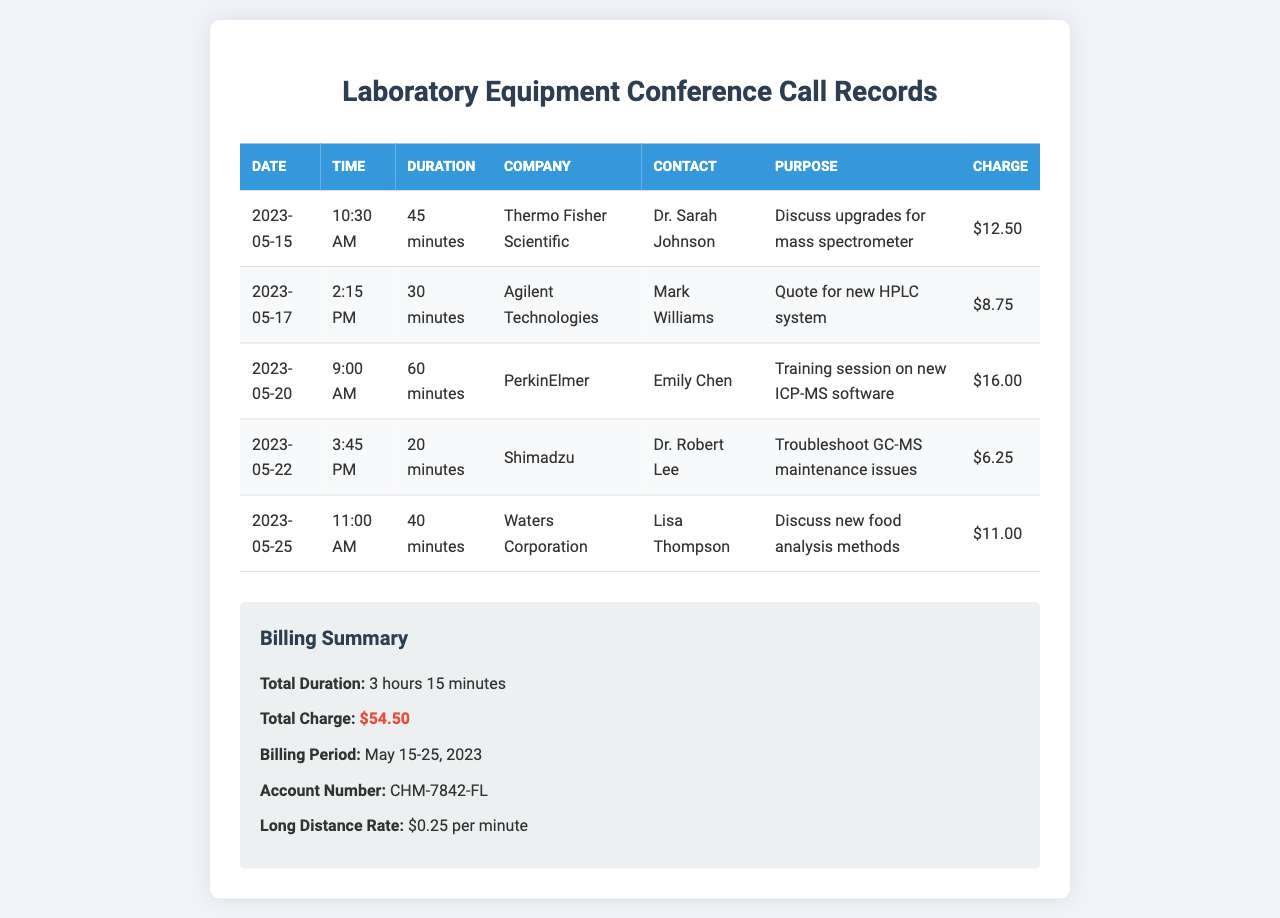What is the total charge? The total charge is the sum of all long-distance charges listed in the document.
Answer: $54.50 How many minutes was the longest call? The longest call duration listed in the document is 60 minutes.
Answer: 60 minutes Who was the contact person for Waters Corporation? The contact person for Waters Corporation mentioned in the document is Lisa Thompson.
Answer: Lisa Thompson On what date was the call with Thermo Fisher Scientific made? The call with Thermo Fisher Scientific took place on May 15, 2023.
Answer: May 15, 2023 What was the purpose of the call with Agilent Technologies? The purpose of the call with Agilent Technologies was to obtain a quote for a new HPLC system.
Answer: Quote for new HPLC system What is the total duration of all calls listed in the document? The total duration is the sum of all individual call durations, which amounts to 3 hours 15 minutes.
Answer: 3 hours 15 minutes Which company had the shortest call duration? The company with the shortest call duration listed in the document is Shimadzu, with a call duration of 20 minutes.
Answer: Shimadzu What is the long-distance rate per minute? The document states that the long-distance rate is $0.25 per minute.
Answer: $0.25 per minute What is the billing period for the calls? The billing period for the calls is indicated as May 15 to May 25, 2023.
Answer: May 15-25, 2023 